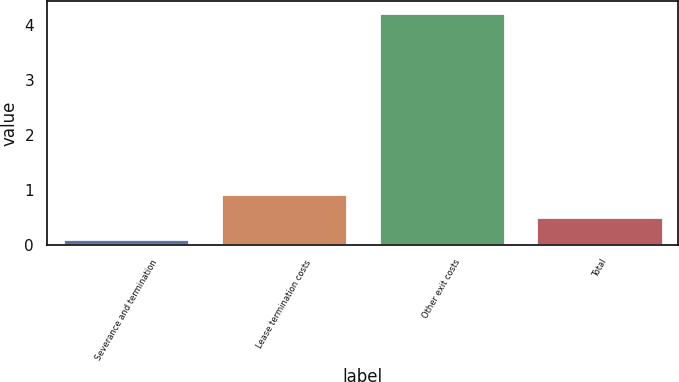Convert chart to OTSL. <chart><loc_0><loc_0><loc_500><loc_500><bar_chart><fcel>Severance and termination<fcel>Lease termination costs<fcel>Other exit costs<fcel>Total<nl><fcel>0.1<fcel>0.92<fcel>4.22<fcel>0.51<nl></chart> 